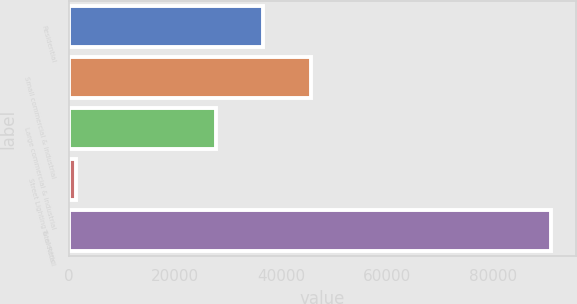<chart> <loc_0><loc_0><loc_500><loc_500><bar_chart><fcel>Residential<fcel>Small commercial & industrial<fcel>Large commercial & industrial<fcel>Street Lighting & electric<fcel>Total Retail<nl><fcel>36696.2<fcel>45675.4<fcel>27717<fcel>1273<fcel>91065<nl></chart> 